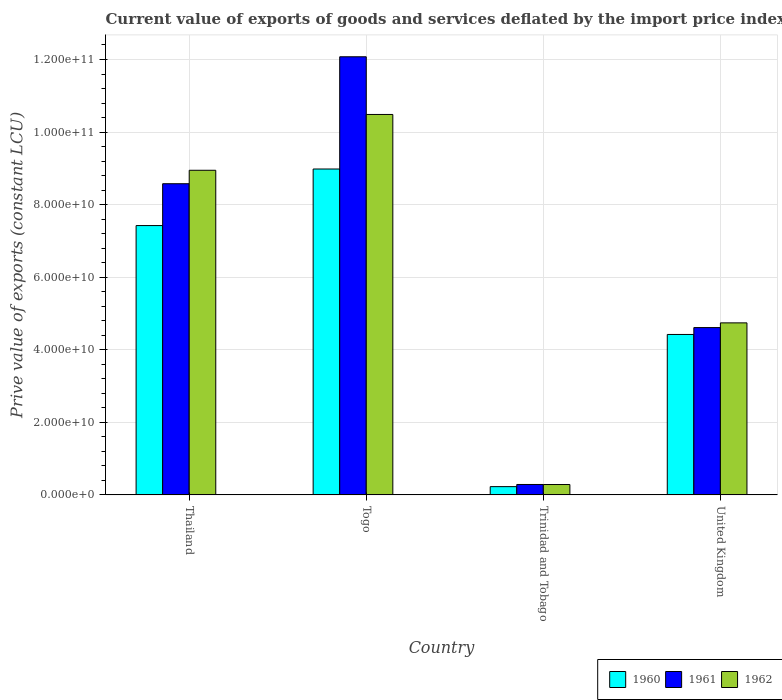How many different coloured bars are there?
Give a very brief answer. 3. How many bars are there on the 1st tick from the left?
Your answer should be very brief. 3. How many bars are there on the 4th tick from the right?
Give a very brief answer. 3. What is the label of the 1st group of bars from the left?
Your answer should be compact. Thailand. What is the prive value of exports in 1962 in United Kingdom?
Offer a terse response. 4.74e+1. Across all countries, what is the maximum prive value of exports in 1961?
Ensure brevity in your answer.  1.21e+11. Across all countries, what is the minimum prive value of exports in 1961?
Your answer should be compact. 2.87e+09. In which country was the prive value of exports in 1960 maximum?
Provide a short and direct response. Togo. In which country was the prive value of exports in 1961 minimum?
Ensure brevity in your answer.  Trinidad and Tobago. What is the total prive value of exports in 1960 in the graph?
Your answer should be compact. 2.11e+11. What is the difference between the prive value of exports in 1960 in Togo and that in Trinidad and Tobago?
Make the answer very short. 8.75e+1. What is the difference between the prive value of exports in 1960 in Trinidad and Tobago and the prive value of exports in 1961 in Thailand?
Your answer should be very brief. -8.35e+1. What is the average prive value of exports in 1961 per country?
Keep it short and to the point. 6.39e+1. What is the difference between the prive value of exports of/in 1960 and prive value of exports of/in 1961 in Togo?
Offer a terse response. -3.09e+1. In how many countries, is the prive value of exports in 1962 greater than 112000000000 LCU?
Offer a terse response. 0. What is the ratio of the prive value of exports in 1962 in Togo to that in Trinidad and Tobago?
Keep it short and to the point. 36.71. What is the difference between the highest and the second highest prive value of exports in 1960?
Offer a very short reply. 4.56e+1. What is the difference between the highest and the lowest prive value of exports in 1961?
Keep it short and to the point. 1.18e+11. Is the sum of the prive value of exports in 1960 in Togo and United Kingdom greater than the maximum prive value of exports in 1962 across all countries?
Your answer should be very brief. Yes. What does the 3rd bar from the left in Trinidad and Tobago represents?
Make the answer very short. 1962. What does the 2nd bar from the right in Thailand represents?
Offer a terse response. 1961. Is it the case that in every country, the sum of the prive value of exports in 1961 and prive value of exports in 1962 is greater than the prive value of exports in 1960?
Your response must be concise. Yes. How many bars are there?
Your response must be concise. 12. How many countries are there in the graph?
Provide a short and direct response. 4. What is the difference between two consecutive major ticks on the Y-axis?
Keep it short and to the point. 2.00e+1. Are the values on the major ticks of Y-axis written in scientific E-notation?
Ensure brevity in your answer.  Yes. Does the graph contain grids?
Your answer should be very brief. Yes. Where does the legend appear in the graph?
Make the answer very short. Bottom right. What is the title of the graph?
Your response must be concise. Current value of exports of goods and services deflated by the import price index. What is the label or title of the Y-axis?
Provide a short and direct response. Prive value of exports (constant LCU). What is the Prive value of exports (constant LCU) of 1960 in Thailand?
Ensure brevity in your answer.  7.42e+1. What is the Prive value of exports (constant LCU) in 1961 in Thailand?
Offer a very short reply. 8.58e+1. What is the Prive value of exports (constant LCU) of 1962 in Thailand?
Your answer should be very brief. 8.95e+1. What is the Prive value of exports (constant LCU) in 1960 in Togo?
Keep it short and to the point. 8.98e+1. What is the Prive value of exports (constant LCU) of 1961 in Togo?
Keep it short and to the point. 1.21e+11. What is the Prive value of exports (constant LCU) of 1962 in Togo?
Your answer should be compact. 1.05e+11. What is the Prive value of exports (constant LCU) in 1960 in Trinidad and Tobago?
Make the answer very short. 2.28e+09. What is the Prive value of exports (constant LCU) of 1961 in Trinidad and Tobago?
Keep it short and to the point. 2.87e+09. What is the Prive value of exports (constant LCU) in 1962 in Trinidad and Tobago?
Your answer should be compact. 2.86e+09. What is the Prive value of exports (constant LCU) in 1960 in United Kingdom?
Make the answer very short. 4.42e+1. What is the Prive value of exports (constant LCU) of 1961 in United Kingdom?
Offer a very short reply. 4.61e+1. What is the Prive value of exports (constant LCU) in 1962 in United Kingdom?
Offer a very short reply. 4.74e+1. Across all countries, what is the maximum Prive value of exports (constant LCU) in 1960?
Your answer should be compact. 8.98e+1. Across all countries, what is the maximum Prive value of exports (constant LCU) of 1961?
Keep it short and to the point. 1.21e+11. Across all countries, what is the maximum Prive value of exports (constant LCU) of 1962?
Provide a succinct answer. 1.05e+11. Across all countries, what is the minimum Prive value of exports (constant LCU) of 1960?
Your answer should be compact. 2.28e+09. Across all countries, what is the minimum Prive value of exports (constant LCU) of 1961?
Offer a terse response. 2.87e+09. Across all countries, what is the minimum Prive value of exports (constant LCU) of 1962?
Ensure brevity in your answer.  2.86e+09. What is the total Prive value of exports (constant LCU) of 1960 in the graph?
Offer a very short reply. 2.11e+11. What is the total Prive value of exports (constant LCU) in 1961 in the graph?
Your response must be concise. 2.55e+11. What is the total Prive value of exports (constant LCU) of 1962 in the graph?
Ensure brevity in your answer.  2.45e+11. What is the difference between the Prive value of exports (constant LCU) in 1960 in Thailand and that in Togo?
Give a very brief answer. -1.56e+1. What is the difference between the Prive value of exports (constant LCU) of 1961 in Thailand and that in Togo?
Provide a short and direct response. -3.50e+1. What is the difference between the Prive value of exports (constant LCU) of 1962 in Thailand and that in Togo?
Offer a very short reply. -1.54e+1. What is the difference between the Prive value of exports (constant LCU) in 1960 in Thailand and that in Trinidad and Tobago?
Your answer should be very brief. 7.20e+1. What is the difference between the Prive value of exports (constant LCU) of 1961 in Thailand and that in Trinidad and Tobago?
Your answer should be very brief. 8.29e+1. What is the difference between the Prive value of exports (constant LCU) in 1962 in Thailand and that in Trinidad and Tobago?
Your response must be concise. 8.66e+1. What is the difference between the Prive value of exports (constant LCU) in 1960 in Thailand and that in United Kingdom?
Offer a terse response. 3.00e+1. What is the difference between the Prive value of exports (constant LCU) of 1961 in Thailand and that in United Kingdom?
Your answer should be very brief. 3.96e+1. What is the difference between the Prive value of exports (constant LCU) of 1962 in Thailand and that in United Kingdom?
Your answer should be very brief. 4.21e+1. What is the difference between the Prive value of exports (constant LCU) in 1960 in Togo and that in Trinidad and Tobago?
Give a very brief answer. 8.75e+1. What is the difference between the Prive value of exports (constant LCU) of 1961 in Togo and that in Trinidad and Tobago?
Your answer should be very brief. 1.18e+11. What is the difference between the Prive value of exports (constant LCU) in 1962 in Togo and that in Trinidad and Tobago?
Offer a very short reply. 1.02e+11. What is the difference between the Prive value of exports (constant LCU) in 1960 in Togo and that in United Kingdom?
Your answer should be very brief. 4.56e+1. What is the difference between the Prive value of exports (constant LCU) in 1961 in Togo and that in United Kingdom?
Your answer should be compact. 7.46e+1. What is the difference between the Prive value of exports (constant LCU) in 1962 in Togo and that in United Kingdom?
Ensure brevity in your answer.  5.74e+1. What is the difference between the Prive value of exports (constant LCU) of 1960 in Trinidad and Tobago and that in United Kingdom?
Your response must be concise. -4.19e+1. What is the difference between the Prive value of exports (constant LCU) in 1961 in Trinidad and Tobago and that in United Kingdom?
Give a very brief answer. -4.32e+1. What is the difference between the Prive value of exports (constant LCU) in 1962 in Trinidad and Tobago and that in United Kingdom?
Ensure brevity in your answer.  -4.46e+1. What is the difference between the Prive value of exports (constant LCU) of 1960 in Thailand and the Prive value of exports (constant LCU) of 1961 in Togo?
Your answer should be compact. -4.65e+1. What is the difference between the Prive value of exports (constant LCU) of 1960 in Thailand and the Prive value of exports (constant LCU) of 1962 in Togo?
Your answer should be compact. -3.06e+1. What is the difference between the Prive value of exports (constant LCU) in 1961 in Thailand and the Prive value of exports (constant LCU) in 1962 in Togo?
Provide a short and direct response. -1.91e+1. What is the difference between the Prive value of exports (constant LCU) of 1960 in Thailand and the Prive value of exports (constant LCU) of 1961 in Trinidad and Tobago?
Make the answer very short. 7.14e+1. What is the difference between the Prive value of exports (constant LCU) of 1960 in Thailand and the Prive value of exports (constant LCU) of 1962 in Trinidad and Tobago?
Offer a terse response. 7.14e+1. What is the difference between the Prive value of exports (constant LCU) of 1961 in Thailand and the Prive value of exports (constant LCU) of 1962 in Trinidad and Tobago?
Offer a terse response. 8.29e+1. What is the difference between the Prive value of exports (constant LCU) in 1960 in Thailand and the Prive value of exports (constant LCU) in 1961 in United Kingdom?
Offer a very short reply. 2.81e+1. What is the difference between the Prive value of exports (constant LCU) of 1960 in Thailand and the Prive value of exports (constant LCU) of 1962 in United Kingdom?
Give a very brief answer. 2.68e+1. What is the difference between the Prive value of exports (constant LCU) of 1961 in Thailand and the Prive value of exports (constant LCU) of 1962 in United Kingdom?
Offer a very short reply. 3.84e+1. What is the difference between the Prive value of exports (constant LCU) of 1960 in Togo and the Prive value of exports (constant LCU) of 1961 in Trinidad and Tobago?
Your response must be concise. 8.69e+1. What is the difference between the Prive value of exports (constant LCU) in 1960 in Togo and the Prive value of exports (constant LCU) in 1962 in Trinidad and Tobago?
Provide a succinct answer. 8.70e+1. What is the difference between the Prive value of exports (constant LCU) of 1961 in Togo and the Prive value of exports (constant LCU) of 1962 in Trinidad and Tobago?
Your response must be concise. 1.18e+11. What is the difference between the Prive value of exports (constant LCU) in 1960 in Togo and the Prive value of exports (constant LCU) in 1961 in United Kingdom?
Ensure brevity in your answer.  4.37e+1. What is the difference between the Prive value of exports (constant LCU) in 1960 in Togo and the Prive value of exports (constant LCU) in 1962 in United Kingdom?
Offer a terse response. 4.24e+1. What is the difference between the Prive value of exports (constant LCU) in 1961 in Togo and the Prive value of exports (constant LCU) in 1962 in United Kingdom?
Offer a very short reply. 7.33e+1. What is the difference between the Prive value of exports (constant LCU) of 1960 in Trinidad and Tobago and the Prive value of exports (constant LCU) of 1961 in United Kingdom?
Ensure brevity in your answer.  -4.38e+1. What is the difference between the Prive value of exports (constant LCU) in 1960 in Trinidad and Tobago and the Prive value of exports (constant LCU) in 1962 in United Kingdom?
Offer a terse response. -4.51e+1. What is the difference between the Prive value of exports (constant LCU) in 1961 in Trinidad and Tobago and the Prive value of exports (constant LCU) in 1962 in United Kingdom?
Keep it short and to the point. -4.45e+1. What is the average Prive value of exports (constant LCU) in 1960 per country?
Provide a short and direct response. 5.26e+1. What is the average Prive value of exports (constant LCU) of 1961 per country?
Give a very brief answer. 6.39e+1. What is the average Prive value of exports (constant LCU) of 1962 per country?
Give a very brief answer. 6.11e+1. What is the difference between the Prive value of exports (constant LCU) of 1960 and Prive value of exports (constant LCU) of 1961 in Thailand?
Ensure brevity in your answer.  -1.15e+1. What is the difference between the Prive value of exports (constant LCU) in 1960 and Prive value of exports (constant LCU) in 1962 in Thailand?
Make the answer very short. -1.52e+1. What is the difference between the Prive value of exports (constant LCU) in 1961 and Prive value of exports (constant LCU) in 1962 in Thailand?
Ensure brevity in your answer.  -3.71e+09. What is the difference between the Prive value of exports (constant LCU) of 1960 and Prive value of exports (constant LCU) of 1961 in Togo?
Offer a very short reply. -3.09e+1. What is the difference between the Prive value of exports (constant LCU) in 1960 and Prive value of exports (constant LCU) in 1962 in Togo?
Your answer should be compact. -1.50e+1. What is the difference between the Prive value of exports (constant LCU) of 1961 and Prive value of exports (constant LCU) of 1962 in Togo?
Your answer should be very brief. 1.59e+1. What is the difference between the Prive value of exports (constant LCU) of 1960 and Prive value of exports (constant LCU) of 1961 in Trinidad and Tobago?
Your response must be concise. -5.92e+08. What is the difference between the Prive value of exports (constant LCU) in 1960 and Prive value of exports (constant LCU) in 1962 in Trinidad and Tobago?
Your response must be concise. -5.79e+08. What is the difference between the Prive value of exports (constant LCU) of 1961 and Prive value of exports (constant LCU) of 1962 in Trinidad and Tobago?
Offer a very short reply. 1.28e+07. What is the difference between the Prive value of exports (constant LCU) of 1960 and Prive value of exports (constant LCU) of 1961 in United Kingdom?
Make the answer very short. -1.90e+09. What is the difference between the Prive value of exports (constant LCU) in 1960 and Prive value of exports (constant LCU) in 1962 in United Kingdom?
Ensure brevity in your answer.  -3.20e+09. What is the difference between the Prive value of exports (constant LCU) in 1961 and Prive value of exports (constant LCU) in 1962 in United Kingdom?
Ensure brevity in your answer.  -1.30e+09. What is the ratio of the Prive value of exports (constant LCU) in 1960 in Thailand to that in Togo?
Provide a short and direct response. 0.83. What is the ratio of the Prive value of exports (constant LCU) of 1961 in Thailand to that in Togo?
Your answer should be compact. 0.71. What is the ratio of the Prive value of exports (constant LCU) of 1962 in Thailand to that in Togo?
Your answer should be very brief. 0.85. What is the ratio of the Prive value of exports (constant LCU) in 1960 in Thailand to that in Trinidad and Tobago?
Your answer should be very brief. 32.59. What is the ratio of the Prive value of exports (constant LCU) in 1961 in Thailand to that in Trinidad and Tobago?
Your answer should be very brief. 29.89. What is the ratio of the Prive value of exports (constant LCU) in 1962 in Thailand to that in Trinidad and Tobago?
Your answer should be very brief. 31.32. What is the ratio of the Prive value of exports (constant LCU) in 1960 in Thailand to that in United Kingdom?
Your answer should be compact. 1.68. What is the ratio of the Prive value of exports (constant LCU) of 1961 in Thailand to that in United Kingdom?
Your answer should be compact. 1.86. What is the ratio of the Prive value of exports (constant LCU) in 1962 in Thailand to that in United Kingdom?
Offer a very short reply. 1.89. What is the ratio of the Prive value of exports (constant LCU) of 1960 in Togo to that in Trinidad and Tobago?
Provide a succinct answer. 39.43. What is the ratio of the Prive value of exports (constant LCU) in 1961 in Togo to that in Trinidad and Tobago?
Your response must be concise. 42.08. What is the ratio of the Prive value of exports (constant LCU) in 1962 in Togo to that in Trinidad and Tobago?
Provide a short and direct response. 36.71. What is the ratio of the Prive value of exports (constant LCU) in 1960 in Togo to that in United Kingdom?
Keep it short and to the point. 2.03. What is the ratio of the Prive value of exports (constant LCU) of 1961 in Togo to that in United Kingdom?
Provide a succinct answer. 2.62. What is the ratio of the Prive value of exports (constant LCU) of 1962 in Togo to that in United Kingdom?
Make the answer very short. 2.21. What is the ratio of the Prive value of exports (constant LCU) in 1960 in Trinidad and Tobago to that in United Kingdom?
Provide a succinct answer. 0.05. What is the ratio of the Prive value of exports (constant LCU) in 1961 in Trinidad and Tobago to that in United Kingdom?
Keep it short and to the point. 0.06. What is the ratio of the Prive value of exports (constant LCU) of 1962 in Trinidad and Tobago to that in United Kingdom?
Make the answer very short. 0.06. What is the difference between the highest and the second highest Prive value of exports (constant LCU) in 1960?
Make the answer very short. 1.56e+1. What is the difference between the highest and the second highest Prive value of exports (constant LCU) of 1961?
Offer a terse response. 3.50e+1. What is the difference between the highest and the second highest Prive value of exports (constant LCU) of 1962?
Your answer should be compact. 1.54e+1. What is the difference between the highest and the lowest Prive value of exports (constant LCU) in 1960?
Provide a succinct answer. 8.75e+1. What is the difference between the highest and the lowest Prive value of exports (constant LCU) in 1961?
Make the answer very short. 1.18e+11. What is the difference between the highest and the lowest Prive value of exports (constant LCU) of 1962?
Ensure brevity in your answer.  1.02e+11. 